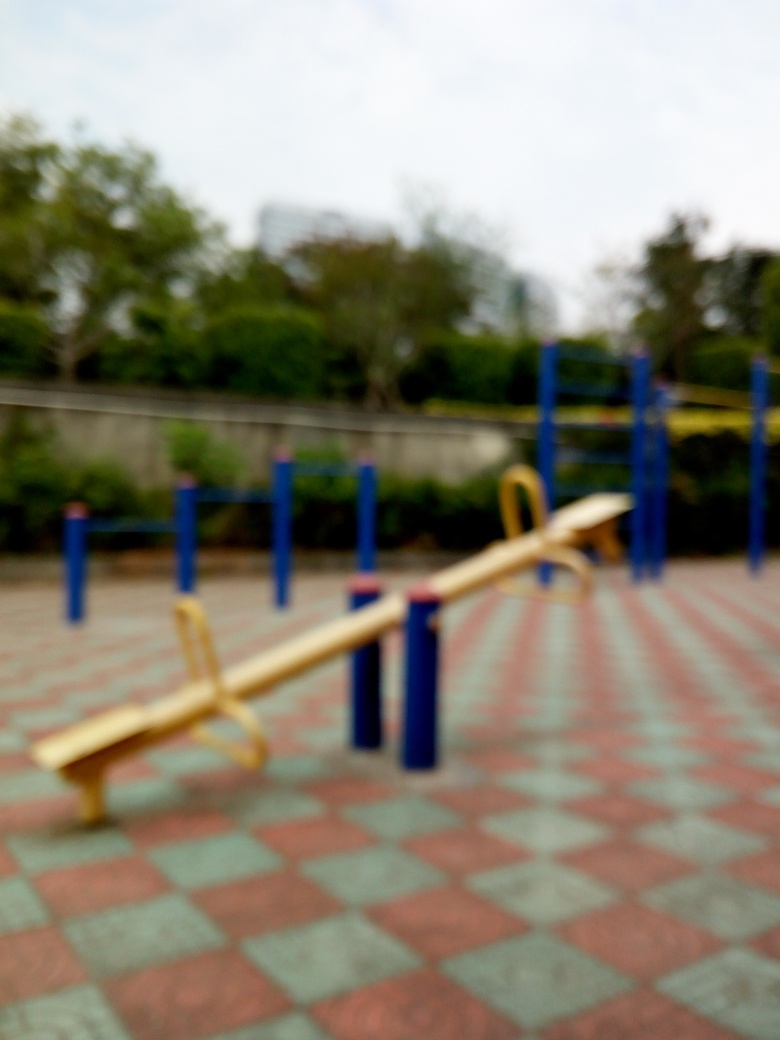Is the content of the image a seesaw in the fitness equipment? The image shows a playground with a seesaw, which is a piece of equipment typically found in children's play areas rather than being categorized as fitness equipment for adults. Seesaws are designed for recreational, rather than fitness purposes. 